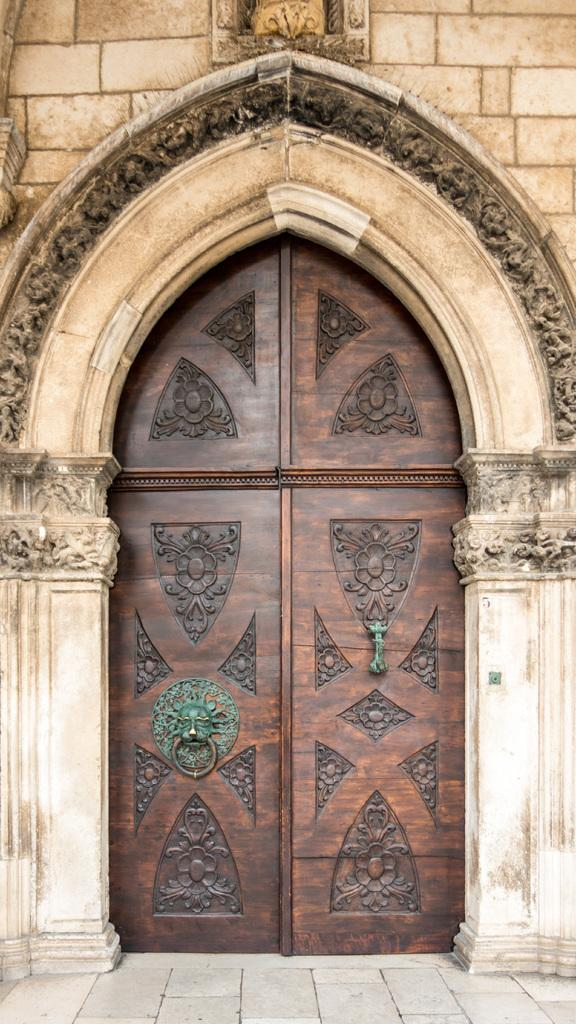What is the main architectural feature in the image? There is a door in the image. Where is the door located in relation to the wall? The door is below a wall. What design element surrounds the door? There is an arch around the door. Are there any decorative features on the arch? Yes, the arch has carvings. What is the current state of the door? The door is closed. How many ants can be seen crawling on the door in the image? There are no ants present in the image. What advice does the mother give about the door in the image? There is no mother present in the image, and no advice is given about the door. 